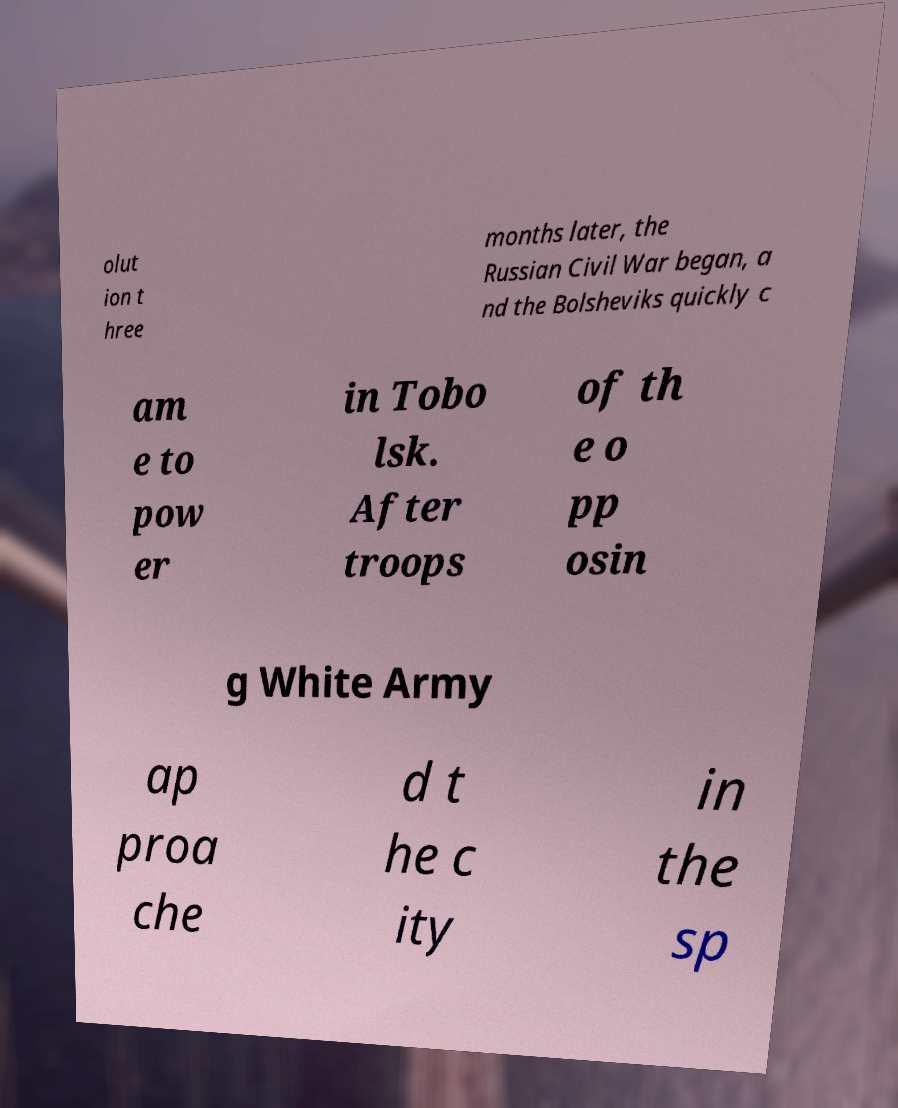For documentation purposes, I need the text within this image transcribed. Could you provide that? olut ion t hree months later, the Russian Civil War began, a nd the Bolsheviks quickly c am e to pow er in Tobo lsk. After troops of th e o pp osin g White Army ap proa che d t he c ity in the sp 